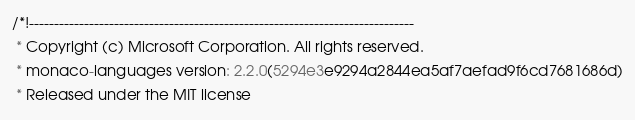<code> <loc_0><loc_0><loc_500><loc_500><_JavaScript_>/*!-----------------------------------------------------------------------------
 * Copyright (c) Microsoft Corporation. All rights reserved.
 * monaco-languages version: 2.2.0(5294e3e9294a2844ea5af7aefad9f6cd7681686d)
 * Released under the MIT license</code> 